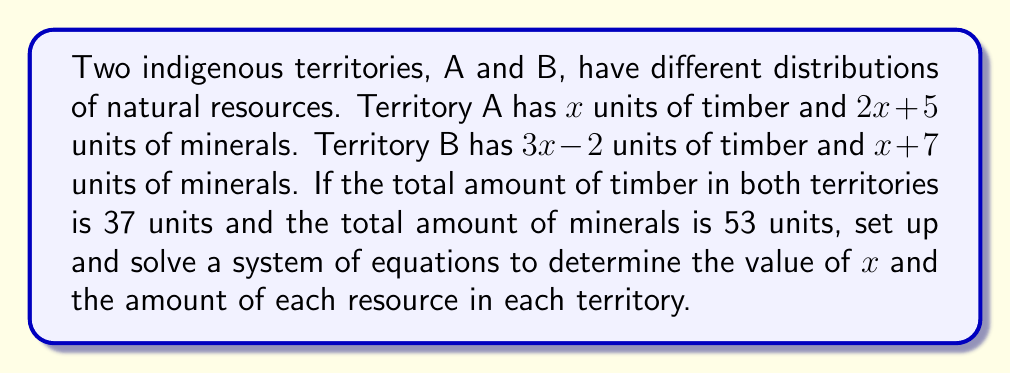Teach me how to tackle this problem. 1) Let's set up the system of equations based on the given information:

   Equation 1 (Timber): $x + (3x - 2) = 37$
   Equation 2 (Minerals): $(2x + 5) + (x + 7) = 53$

2) Simplify Equation 1:
   $4x - 2 = 37$
   $4x = 39$
   $x = \frac{39}{4} = 9.75$

3) Verify the solution using Equation 2:
   $(2(9.75) + 5) + (9.75 + 7) = 53$
   $(19.5 + 5) + (16.75) = 53$
   $24.5 + 16.75 = 41.25 = 53$ (This checks out)

4) Calculate the resources for each territory:

   Territory A:
   Timber: $x = 9.75$ units
   Minerals: $2x + 5 = 2(9.75) + 5 = 24.5$ units

   Territory B:
   Timber: $3x - 2 = 3(9.75) - 2 = 27.25$ units
   Minerals: $x + 7 = 9.75 + 7 = 16.75$ units

5) Verify the totals:
   Total Timber: $9.75 + 27.25 = 37$ units
   Total Minerals: $24.5 + 16.75 = 41.25$ units
Answer: $x = 9.75$; Territory A: 9.75 timber, 24.5 minerals; Territory B: 27.25 timber, 16.75 minerals 